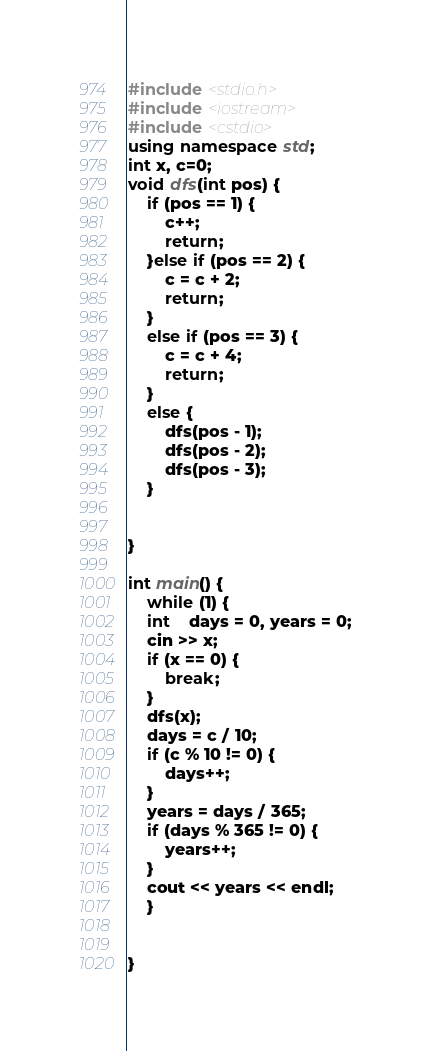<code> <loc_0><loc_0><loc_500><loc_500><_C++_>#include <stdio.h>
#include <iostream>
#include <cstdio>
using namespace std;
int x, c=0;
void dfs(int pos) {
	if (pos == 1) {
		c++;
		return;
	}else if (pos == 2) {
		c = c + 2;
		return;
	}
	else if (pos == 3) {
		c = c + 4;
		return;
	}
	else {
		dfs(pos - 1);
		dfs(pos - 2);
		dfs(pos - 3);
	}


}

int main() {
	while (1) {
	int	days = 0, years = 0;
	cin >> x;
	if (x == 0) {
		break;
	}
	dfs(x);
	days = c / 10;
	if (c % 10 != 0) {
		days++;
	}
	years = days / 365;
	if (days % 365 != 0) {
		years++;
	}
	cout << years << endl;
	}
	

}</code> 